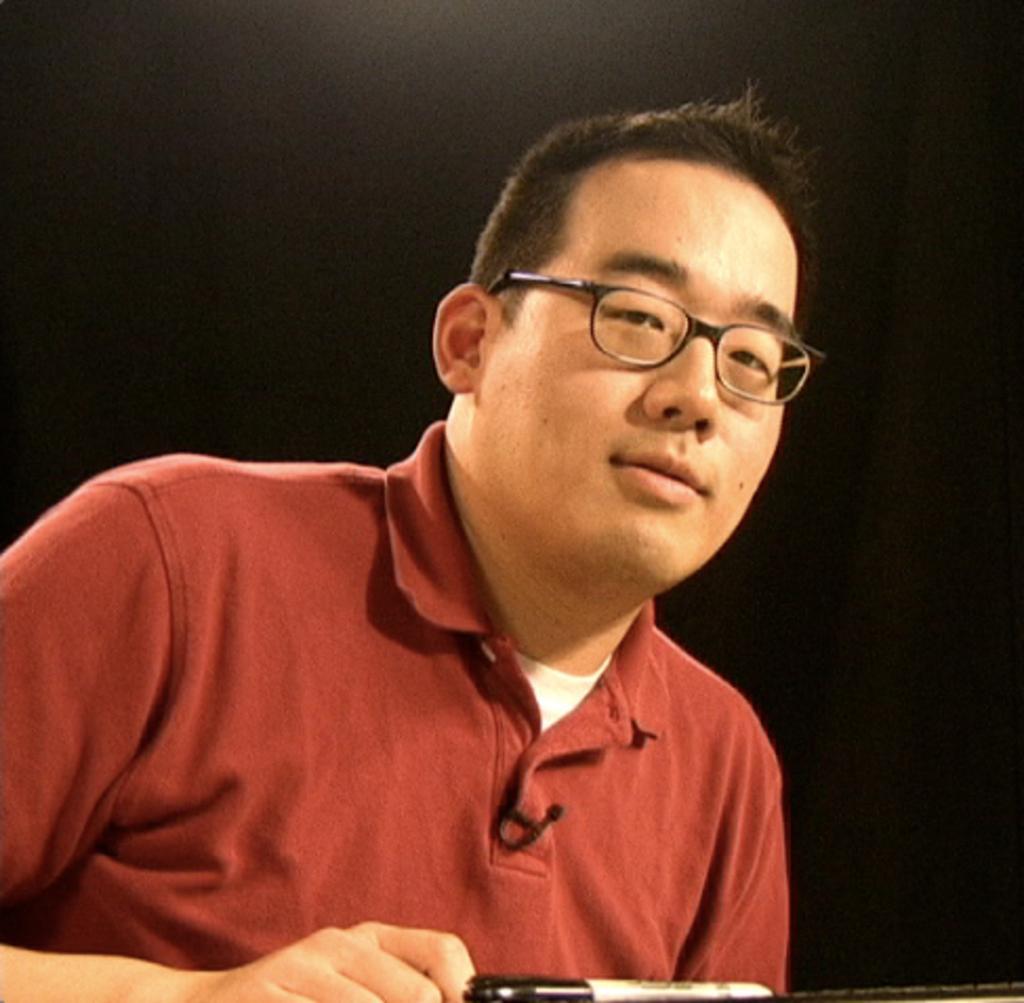How would you summarize this image in a sentence or two? In this image I can see I can see a man in red t shirt. I can see he is wearing a specs. 